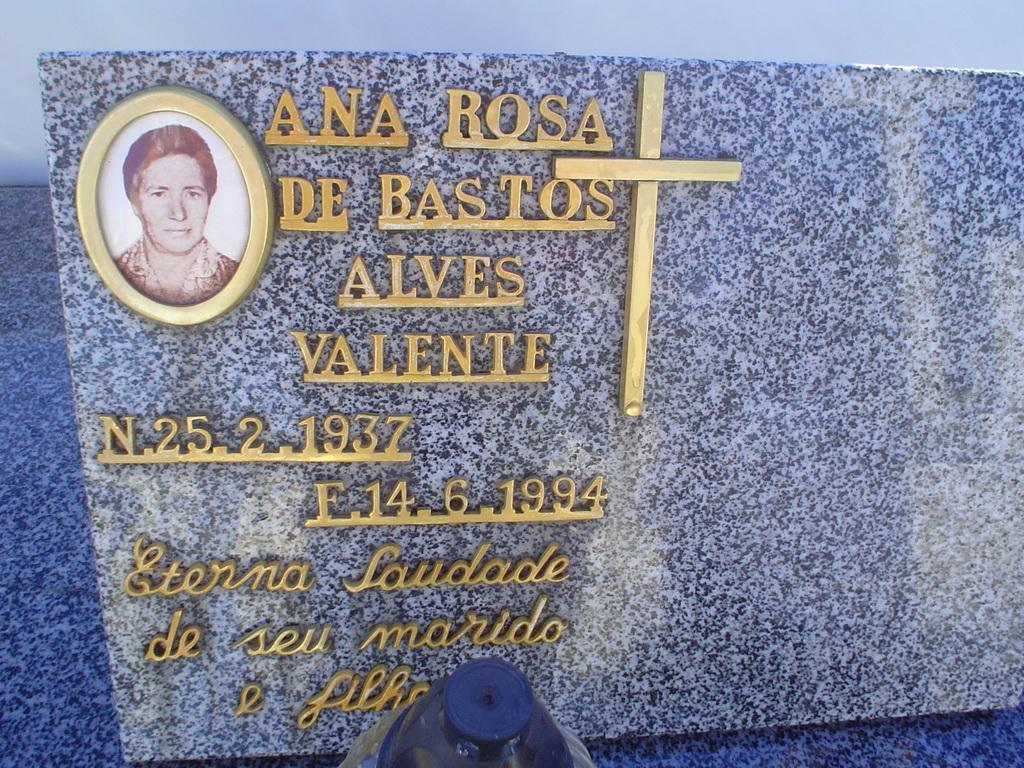What is the main object in the image? There is a memorial stone in the image. What is depicted on the memorial stone? The memorial stone has a photograph on it and a cross. What information is provided on the memorial stone? A name is present on the memorial stone. What can be seen in the background of the image? There is a wall in the background of the image. What type of collar is visible on the star in the image? There is no star or collar present in the image. What color is the cloth draped over the memorial stone? There is no cloth draped over the memorial stone in the image. 